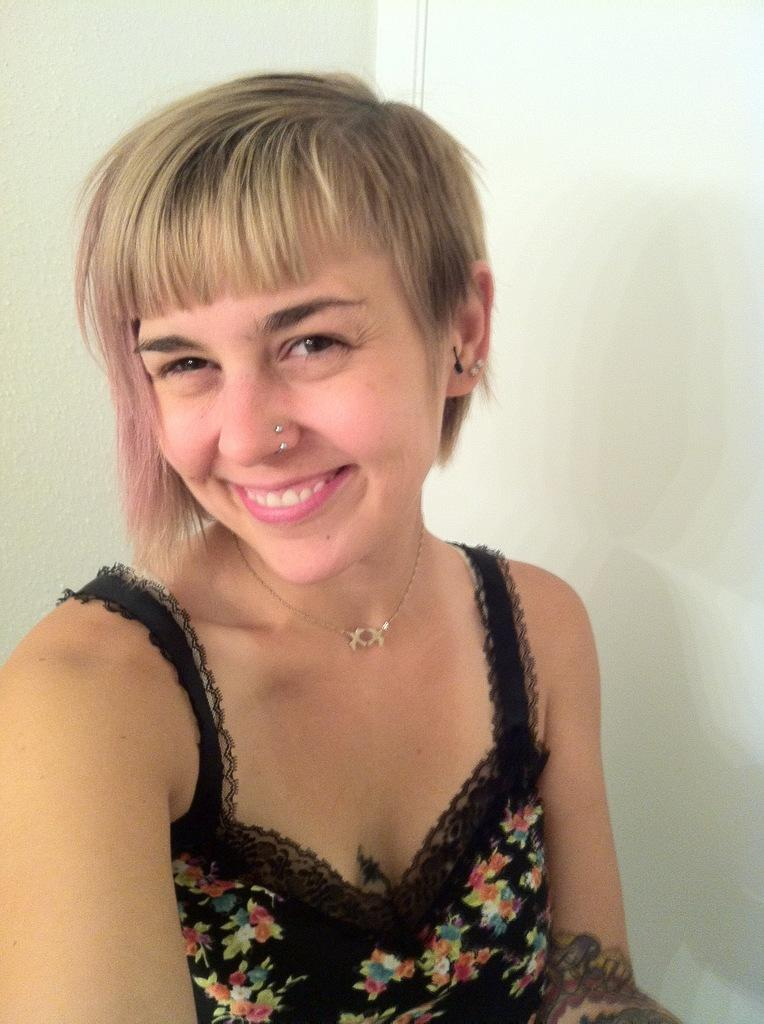What is the main subject of the image? There is a person in the image. What is the person's facial expression? The person is smiling. What color is the dress the person is wearing? The person is wearing a black dress. What type of prose is the person reading in the image? There is no indication in the image that the person is reading any prose. 